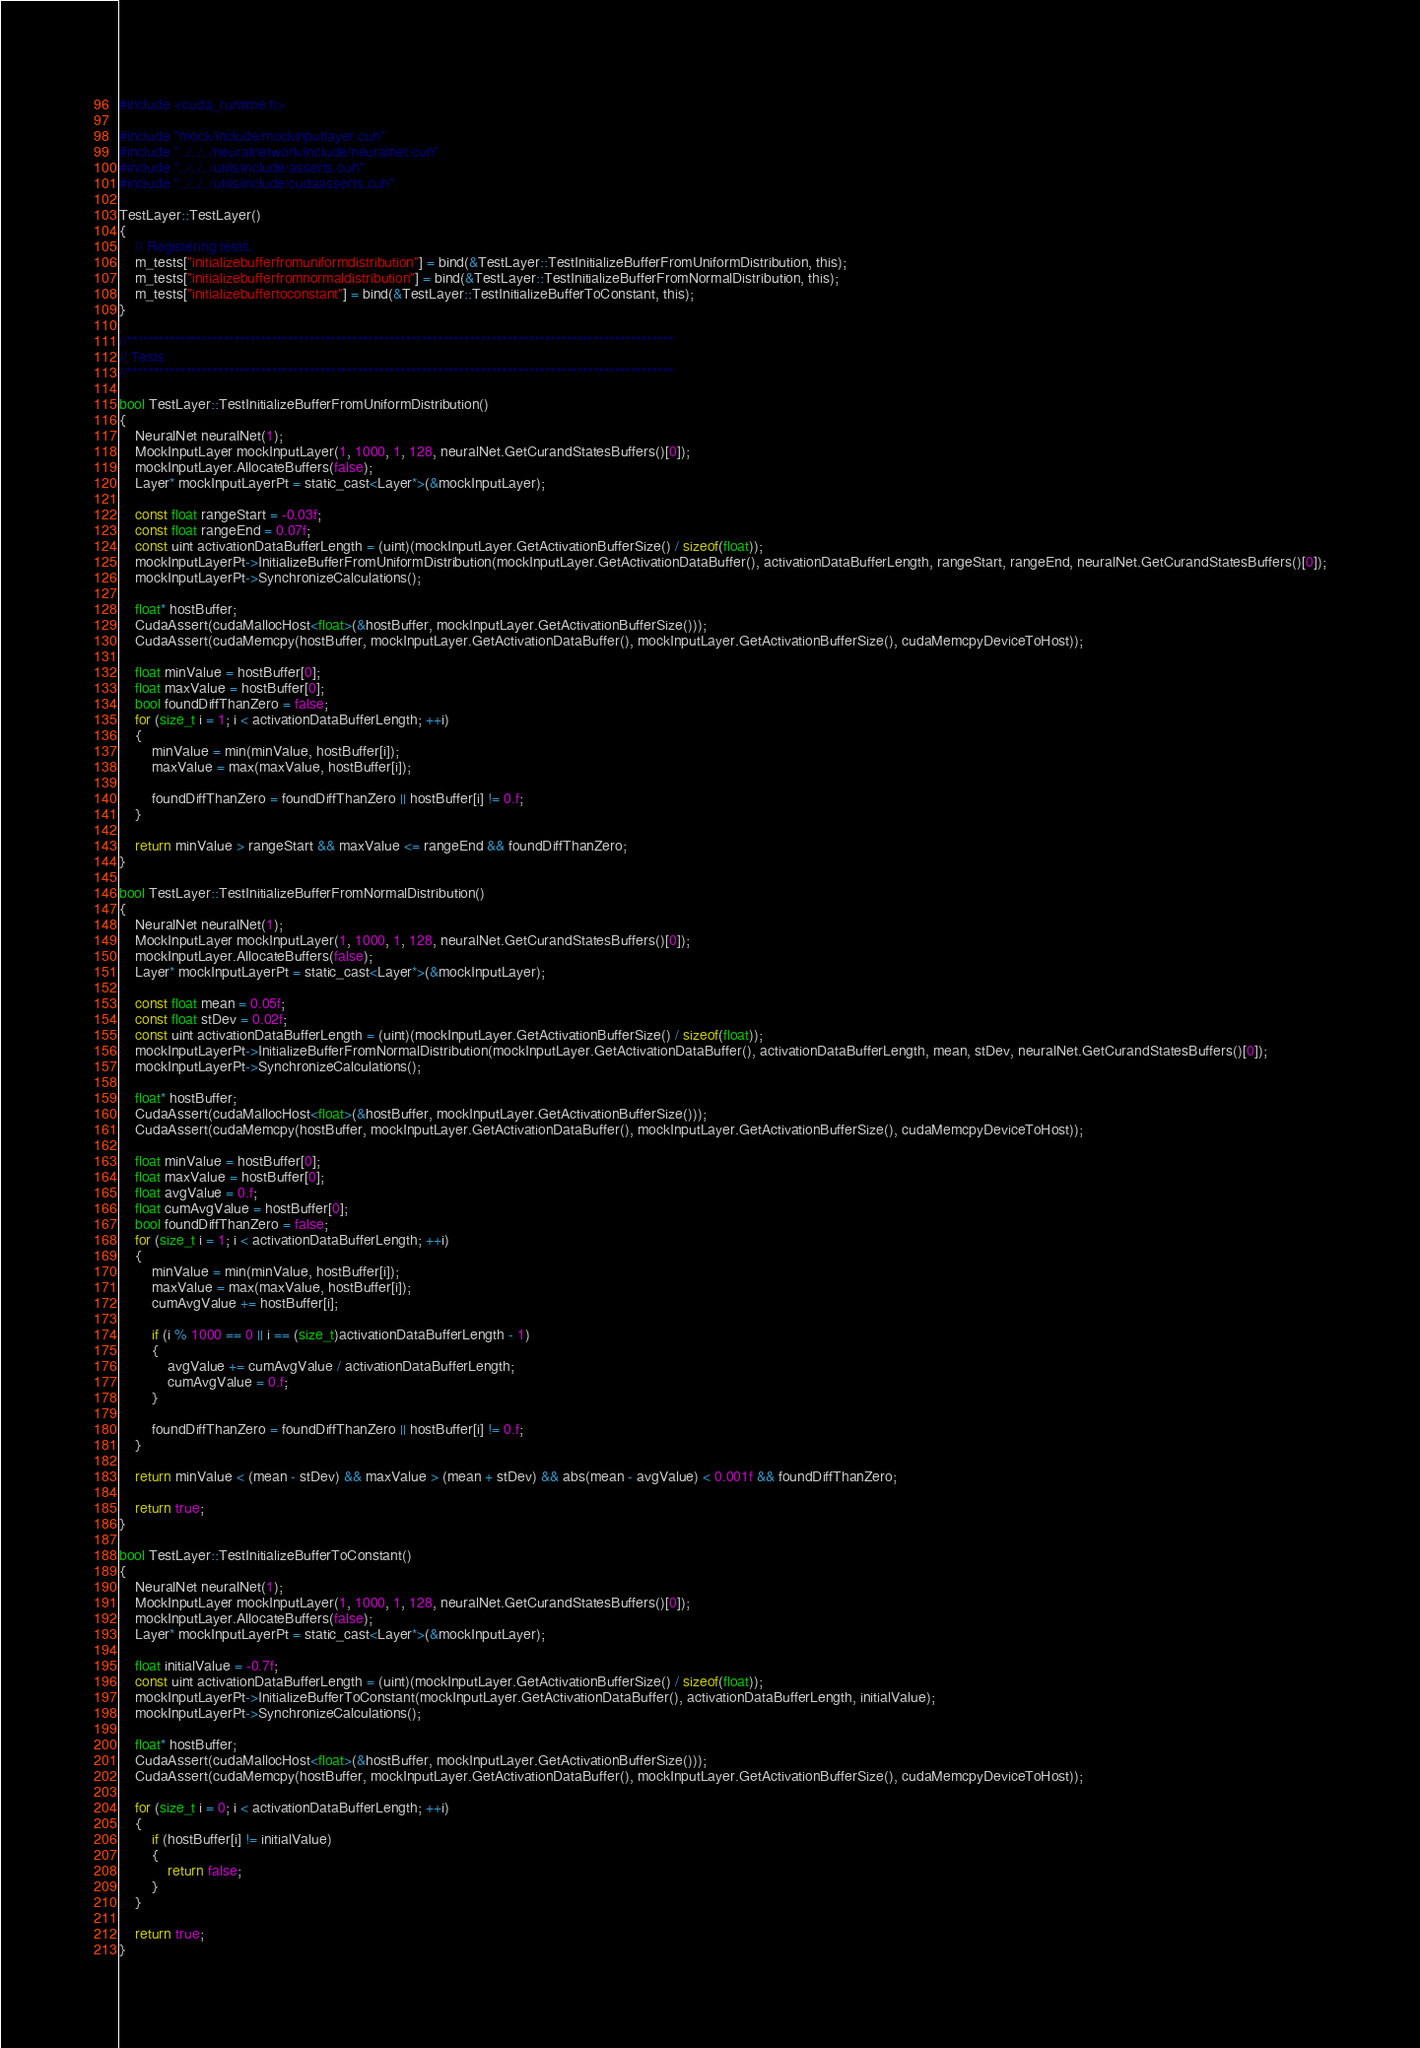<code> <loc_0><loc_0><loc_500><loc_500><_Cuda_>#include <cuda_runtime.h>

#include "mock/include/mockinputlayer.cuh"
#include "../../../neuralnetwork/include/neuralnet.cuh"
#include "../../../utils/include/asserts.cuh"
#include "../../../utils/include/cudaasserts.cuh"

TestLayer::TestLayer()
{
	// Registering tests.
	m_tests["initializebufferfromuniformdistribution"] = bind(&TestLayer::TestInitializeBufferFromUniformDistribution, this);
	m_tests["initializebufferfromnormaldistribution"] = bind(&TestLayer::TestInitializeBufferFromNormalDistribution, this);
	m_tests["initializebuffertoconstant"] = bind(&TestLayer::TestInitializeBufferToConstant, this);
}

//******************************************************************************************************
// Tests
//******************************************************************************************************

bool TestLayer::TestInitializeBufferFromUniformDistribution()
{
	NeuralNet neuralNet(1);
	MockInputLayer mockInputLayer(1, 1000, 1, 128, neuralNet.GetCurandStatesBuffers()[0]);
	mockInputLayer.AllocateBuffers(false);
	Layer* mockInputLayerPt = static_cast<Layer*>(&mockInputLayer);

	const float rangeStart = -0.03f;
	const float rangeEnd = 0.07f;
	const uint activationDataBufferLength = (uint)(mockInputLayer.GetActivationBufferSize() / sizeof(float));
	mockInputLayerPt->InitializeBufferFromUniformDistribution(mockInputLayer.GetActivationDataBuffer(), activationDataBufferLength, rangeStart, rangeEnd, neuralNet.GetCurandStatesBuffers()[0]);
	mockInputLayerPt->SynchronizeCalculations();

	float* hostBuffer;
	CudaAssert(cudaMallocHost<float>(&hostBuffer, mockInputLayer.GetActivationBufferSize()));
	CudaAssert(cudaMemcpy(hostBuffer, mockInputLayer.GetActivationDataBuffer(), mockInputLayer.GetActivationBufferSize(), cudaMemcpyDeviceToHost));

	float minValue = hostBuffer[0];
	float maxValue = hostBuffer[0];
	bool foundDiffThanZero = false;
	for (size_t i = 1; i < activationDataBufferLength; ++i)
	{
		minValue = min(minValue, hostBuffer[i]);
		maxValue = max(maxValue, hostBuffer[i]);

		foundDiffThanZero = foundDiffThanZero || hostBuffer[i] != 0.f;
	}

	return minValue > rangeStart && maxValue <= rangeEnd && foundDiffThanZero;
}

bool TestLayer::TestInitializeBufferFromNormalDistribution()
{
	NeuralNet neuralNet(1);
	MockInputLayer mockInputLayer(1, 1000, 1, 128, neuralNet.GetCurandStatesBuffers()[0]);
	mockInputLayer.AllocateBuffers(false);
	Layer* mockInputLayerPt = static_cast<Layer*>(&mockInputLayer);

	const float mean = 0.05f;
	const float stDev = 0.02f;
	const uint activationDataBufferLength = (uint)(mockInputLayer.GetActivationBufferSize() / sizeof(float));
	mockInputLayerPt->InitializeBufferFromNormalDistribution(mockInputLayer.GetActivationDataBuffer(), activationDataBufferLength, mean, stDev, neuralNet.GetCurandStatesBuffers()[0]);
	mockInputLayerPt->SynchronizeCalculations();

	float* hostBuffer;
	CudaAssert(cudaMallocHost<float>(&hostBuffer, mockInputLayer.GetActivationBufferSize()));
	CudaAssert(cudaMemcpy(hostBuffer, mockInputLayer.GetActivationDataBuffer(), mockInputLayer.GetActivationBufferSize(), cudaMemcpyDeviceToHost));

	float minValue = hostBuffer[0];
	float maxValue = hostBuffer[0];
	float avgValue = 0.f;
	float cumAvgValue = hostBuffer[0];
	bool foundDiffThanZero = false;
	for (size_t i = 1; i < activationDataBufferLength; ++i)
	{
		minValue = min(minValue, hostBuffer[i]);
		maxValue = max(maxValue, hostBuffer[i]);
		cumAvgValue += hostBuffer[i];

		if (i % 1000 == 0 || i == (size_t)activationDataBufferLength - 1)
		{
			avgValue += cumAvgValue / activationDataBufferLength;
			cumAvgValue = 0.f;
		}

		foundDiffThanZero = foundDiffThanZero || hostBuffer[i] != 0.f;
	}

	return minValue < (mean - stDev) && maxValue > (mean + stDev) && abs(mean - avgValue) < 0.001f && foundDiffThanZero;

	return true;
}

bool TestLayer::TestInitializeBufferToConstant()
{
	NeuralNet neuralNet(1);
	MockInputLayer mockInputLayer(1, 1000, 1, 128, neuralNet.GetCurandStatesBuffers()[0]);
	mockInputLayer.AllocateBuffers(false);
	Layer* mockInputLayerPt = static_cast<Layer*>(&mockInputLayer);

	float initialValue = -0.7f;
	const uint activationDataBufferLength = (uint)(mockInputLayer.GetActivationBufferSize() / sizeof(float));
	mockInputLayerPt->InitializeBufferToConstant(mockInputLayer.GetActivationDataBuffer(), activationDataBufferLength, initialValue);
	mockInputLayerPt->SynchronizeCalculations();

	float* hostBuffer;
	CudaAssert(cudaMallocHost<float>(&hostBuffer, mockInputLayer.GetActivationBufferSize()));
	CudaAssert(cudaMemcpy(hostBuffer, mockInputLayer.GetActivationDataBuffer(), mockInputLayer.GetActivationBufferSize(), cudaMemcpyDeviceToHost));

	for (size_t i = 0; i < activationDataBufferLength; ++i)
	{
		if (hostBuffer[i] != initialValue)
		{
			return false;
		}
	}

	return true;
}</code> 